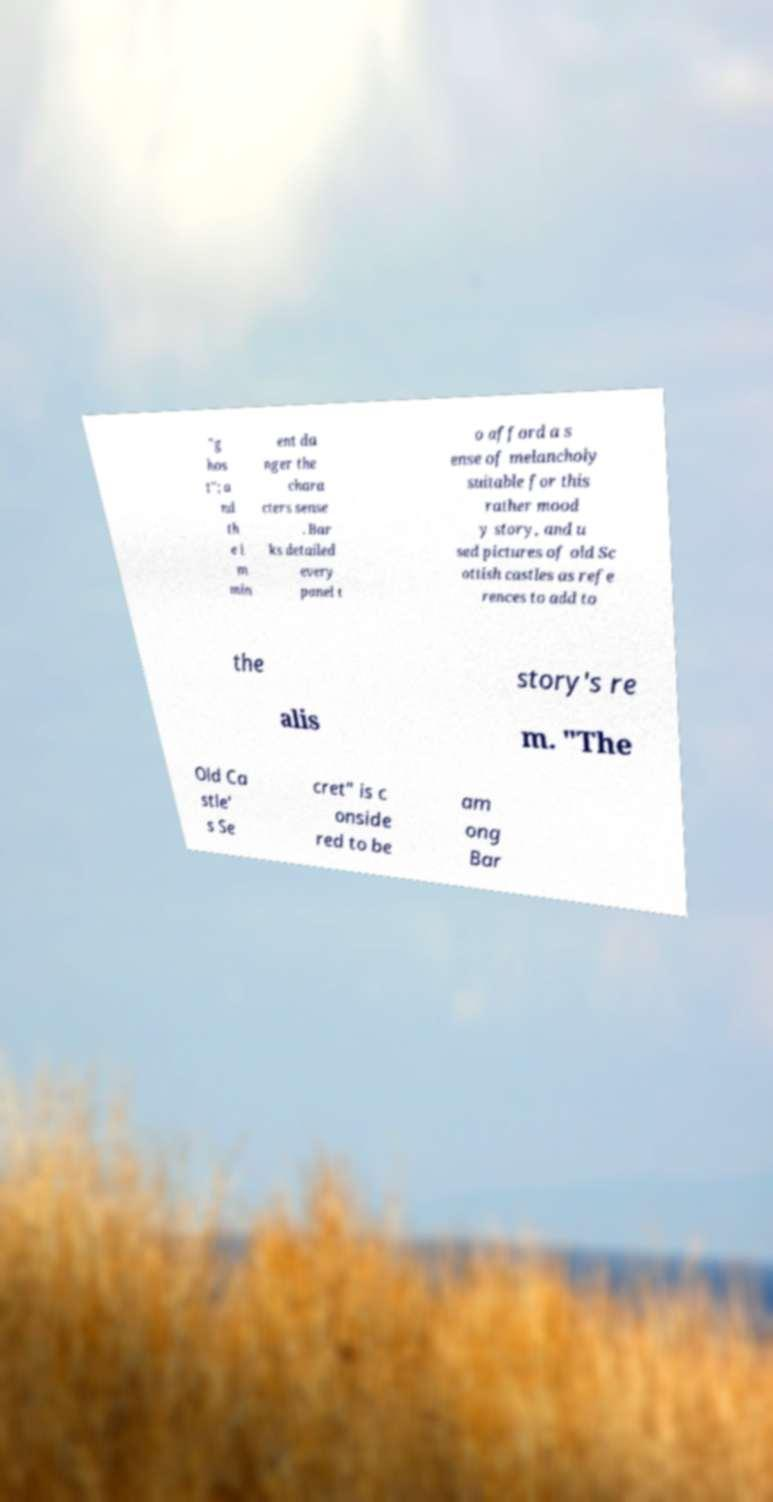Can you accurately transcribe the text from the provided image for me? "g hos t"; a nd th e i m min ent da nger the chara cters sense . Bar ks detailed every panel t o afford a s ense of melancholy suitable for this rather mood y story, and u sed pictures of old Sc ottish castles as refe rences to add to the story's re alis m. "The Old Ca stle' s Se cret" is c onside red to be am ong Bar 